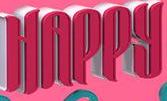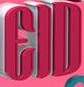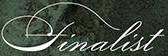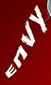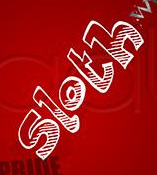What words can you see in these images in sequence, separated by a semicolon? HAPPY; EID; finalist; ENVY; sloth 